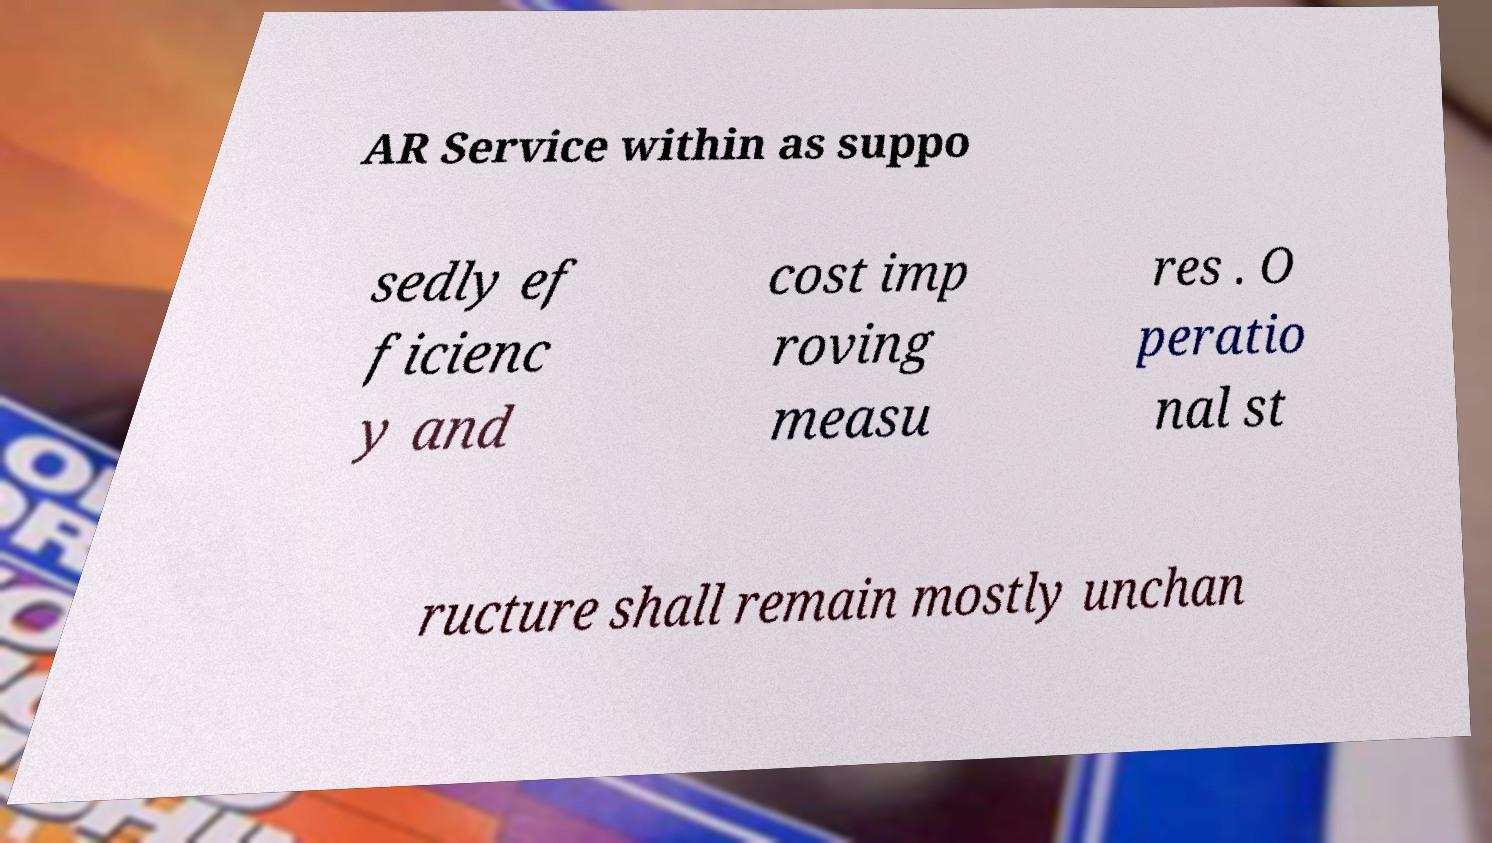Could you extract and type out the text from this image? AR Service within as suppo sedly ef ficienc y and cost imp roving measu res . O peratio nal st ructure shall remain mostly unchan 